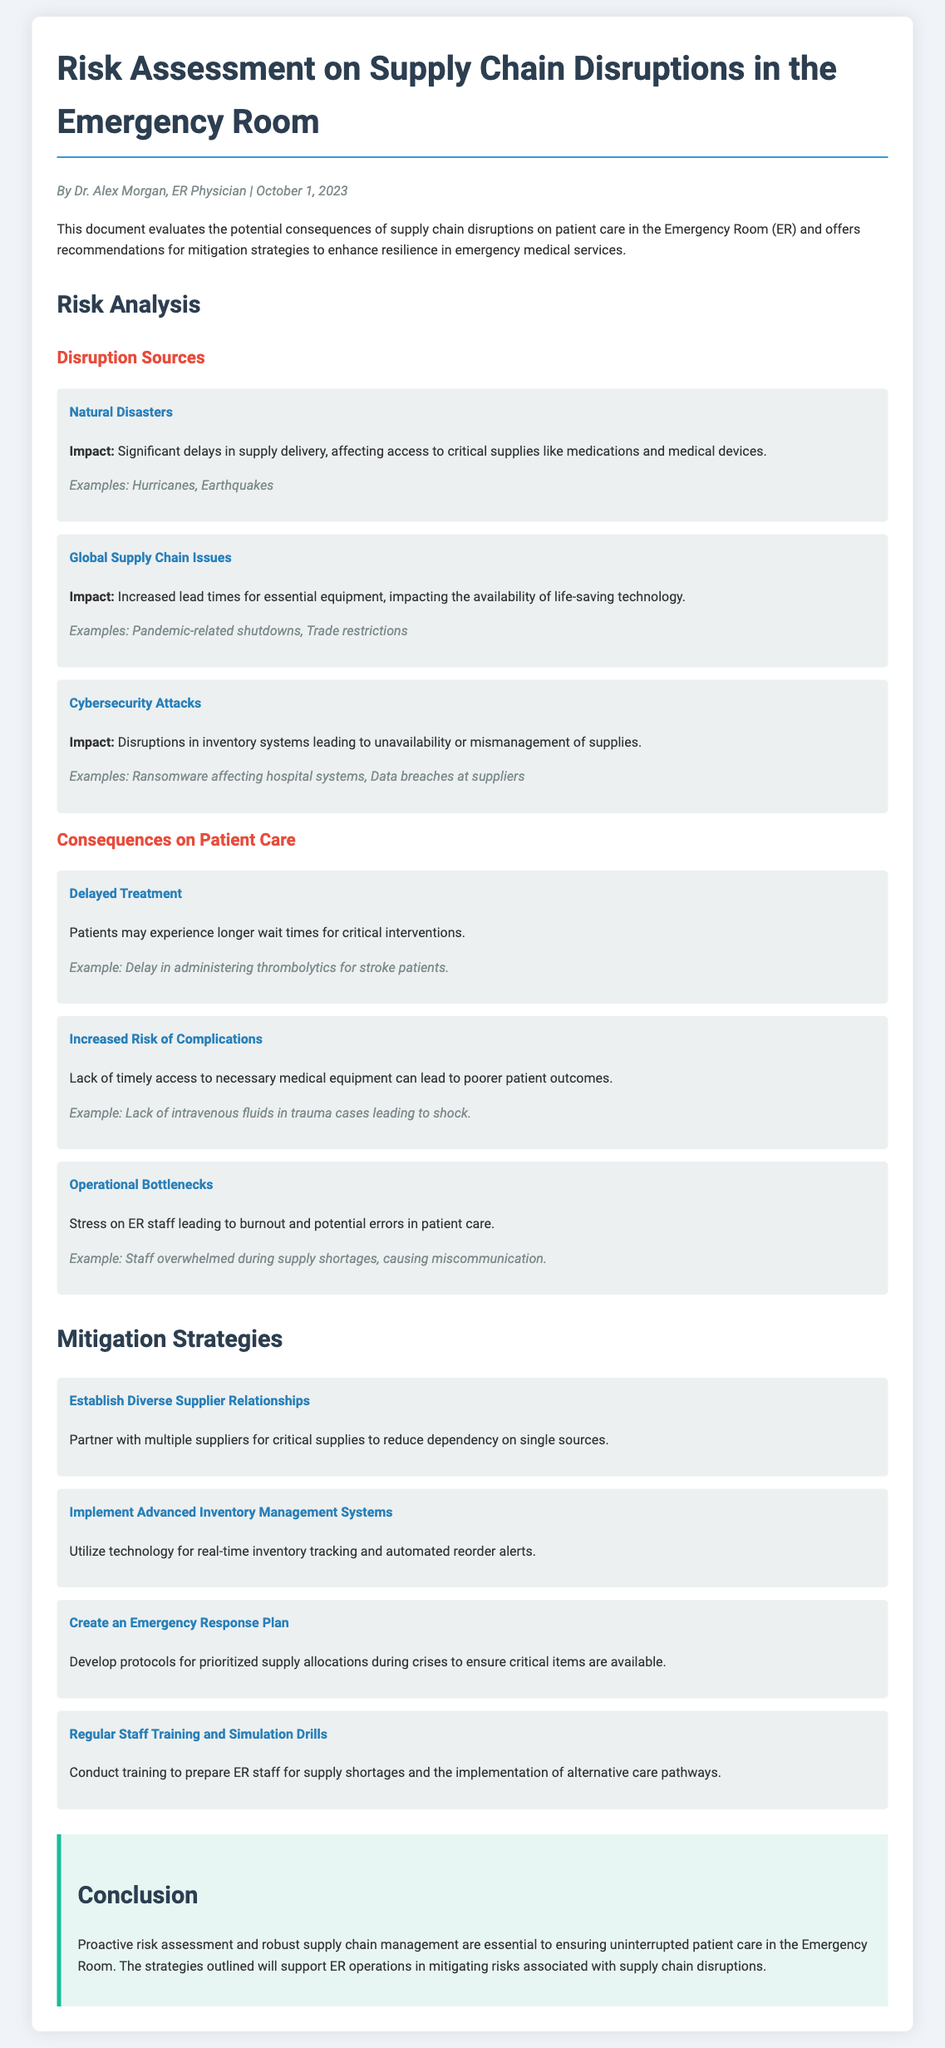What is the title of the document? The title of the document is clearly stated at the top, which is "Risk Assessment on Supply Chain Disruptions in the Emergency Room."
Answer: Risk Assessment on Supply Chain Disruptions in the Emergency Room Who authored the document? The document indicates the author's name and title as Dr. Alex Morgan, an ER Physician.
Answer: Dr. Alex Morgan What is one source of disruption mentioned? The document lists various sources of disruption, one of which is "Natural Disasters."
Answer: Natural Disasters What is one consequence of supply chain disruptions? The document describes several consequences, with "Delayed Treatment" being one of them.
Answer: Delayed Treatment What is one mitigation strategy recommended? The document recommends several strategies, including "Establish Diverse Supplier Relationships."
Answer: Establish Diverse Supplier Relationships What date was the document published? The publication date of the document is included in the author-date section, which is October 1, 2023.
Answer: October 1, 2023 How many consequence items are listed? The document lists three specific consequences of supply chain disruptions on patient care.
Answer: Three What type of document is this? The structure and content indicate that it is a Risk Assessment document focused on supply chain disruptions in the ER.
Answer: Risk Assessment document 